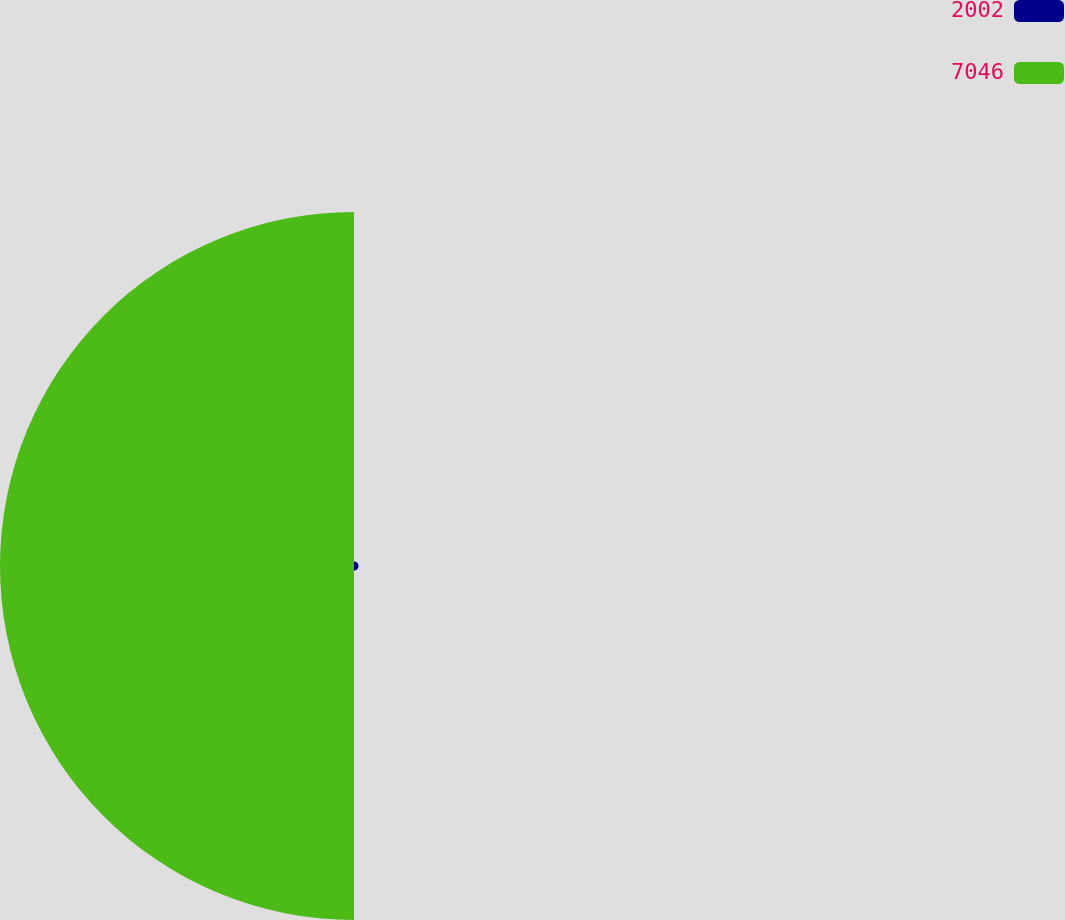Convert chart. <chart><loc_0><loc_0><loc_500><loc_500><pie_chart><fcel>2002<fcel>7046<nl><fcel>1.27%<fcel>98.73%<nl></chart> 